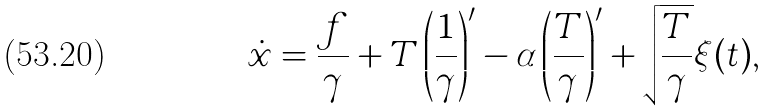<formula> <loc_0><loc_0><loc_500><loc_500>\dot { x } = \frac { f } { \gamma } + T \left ( \frac { 1 } { \gamma } \right ) ^ { \prime } - \alpha \left ( \frac { T } { \gamma } \right ) ^ { \prime } + \sqrt { \frac { T } { \gamma } } \xi ( t ) ,</formula> 